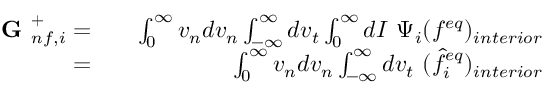Convert formula to latex. <formula><loc_0><loc_0><loc_500><loc_500>\begin{array} { r l r } { G _ { n f , i } ^ { + } = } & { \int _ { 0 } ^ { \infty } v _ { n } d v _ { n } \int _ { - \infty } ^ { \infty } d v _ { t } \int _ { 0 } ^ { \infty } d I \ \Psi _ { i } ( f ^ { e q } ) _ { i n t e r i o r } } \\ { = } & { \int _ { 0 } ^ { \infty } v _ { n } d v _ { n } \int _ { - \infty } ^ { \infty } d v _ { t } \ ( \hat { f } _ { i } ^ { e q } ) _ { i n t e r i o r } } \end{array}</formula> 